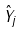<formula> <loc_0><loc_0><loc_500><loc_500>\hat { Y } _ { j }</formula> 